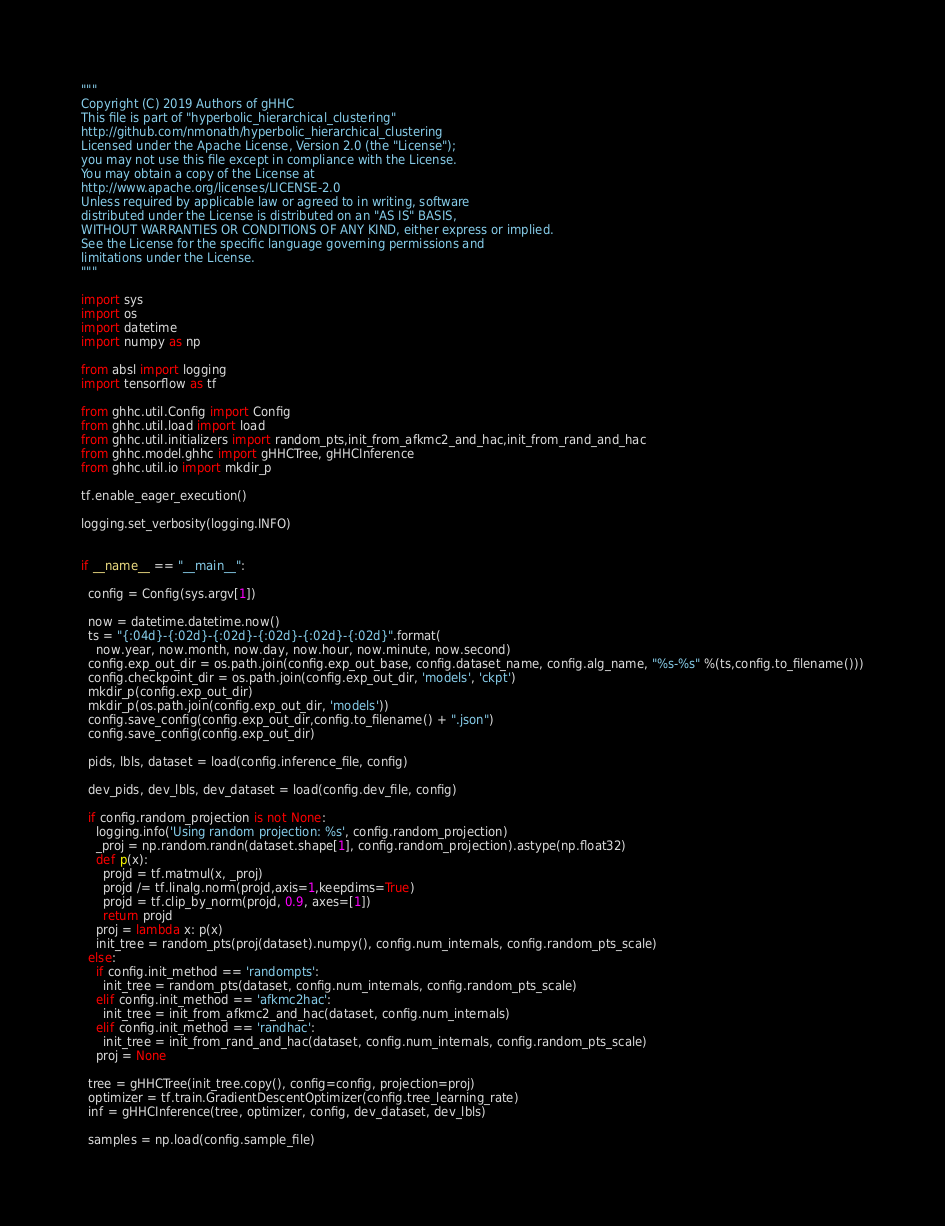Convert code to text. <code><loc_0><loc_0><loc_500><loc_500><_Python_>"""
Copyright (C) 2019 Authors of gHHC
This file is part of "hyperbolic_hierarchical_clustering"
http://github.com/nmonath/hyperbolic_hierarchical_clustering
Licensed under the Apache License, Version 2.0 (the "License");
you may not use this file except in compliance with the License.
You may obtain a copy of the License at
http://www.apache.org/licenses/LICENSE-2.0
Unless required by applicable law or agreed to in writing, software
distributed under the License is distributed on an "AS IS" BASIS,
WITHOUT WARRANTIES OR CONDITIONS OF ANY KIND, either express or implied.
See the License for the specific language governing permissions and
limitations under the License.
"""

import sys
import os
import datetime
import numpy as np

from absl import logging
import tensorflow as tf

from ghhc.util.Config import Config
from ghhc.util.load import load
from ghhc.util.initializers import random_pts,init_from_afkmc2_and_hac,init_from_rand_and_hac
from ghhc.model.ghhc import gHHCTree, gHHCInference
from ghhc.util.io import mkdir_p

tf.enable_eager_execution()

logging.set_verbosity(logging.INFO)


if __name__ == "__main__":

  config = Config(sys.argv[1])

  now = datetime.datetime.now()
  ts = "{:04d}-{:02d}-{:02d}-{:02d}-{:02d}-{:02d}".format(
    now.year, now.month, now.day, now.hour, now.minute, now.second)
  config.exp_out_dir = os.path.join(config.exp_out_base, config.dataset_name, config.alg_name, "%s-%s" %(ts,config.to_filename()))
  config.checkpoint_dir = os.path.join(config.exp_out_dir, 'models', 'ckpt')
  mkdir_p(config.exp_out_dir)
  mkdir_p(os.path.join(config.exp_out_dir, 'models'))
  config.save_config(config.exp_out_dir,config.to_filename() + ".json")
  config.save_config(config.exp_out_dir)

  pids, lbls, dataset = load(config.inference_file, config)

  dev_pids, dev_lbls, dev_dataset = load(config.dev_file, config)

  if config.random_projection is not None:
    logging.info('Using random projection: %s', config.random_projection)
    _proj = np.random.randn(dataset.shape[1], config.random_projection).astype(np.float32)
    def p(x):
      projd = tf.matmul(x, _proj)
      projd /= tf.linalg.norm(projd,axis=1,keepdims=True)
      projd = tf.clip_by_norm(projd, 0.9, axes=[1])
      return projd
    proj = lambda x: p(x)
    init_tree = random_pts(proj(dataset).numpy(), config.num_internals, config.random_pts_scale)
  else:
    if config.init_method == 'randompts':
      init_tree = random_pts(dataset, config.num_internals, config.random_pts_scale)
    elif config.init_method == 'afkmc2hac':
      init_tree = init_from_afkmc2_and_hac(dataset, config.num_internals)
    elif config.init_method == 'randhac':
      init_tree = init_from_rand_and_hac(dataset, config.num_internals, config.random_pts_scale)
    proj = None

  tree = gHHCTree(init_tree.copy(), config=config, projection=proj)
  optimizer = tf.train.GradientDescentOptimizer(config.tree_learning_rate)
  inf = gHHCInference(tree, optimizer, config, dev_dataset, dev_lbls)

  samples = np.load(config.sample_file)</code> 